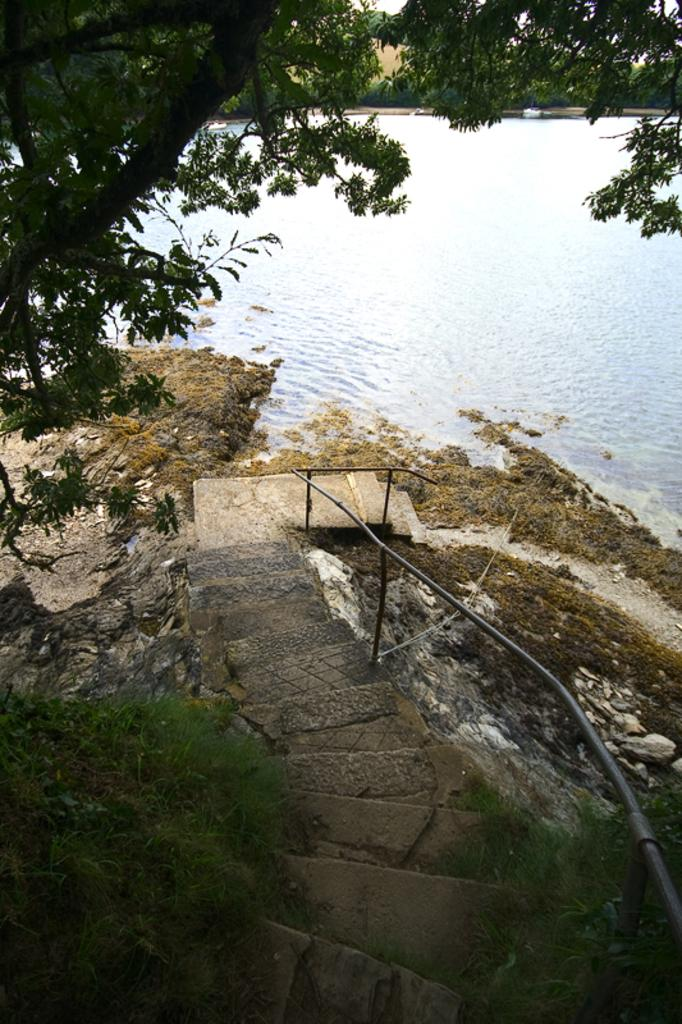What type of vegetation is present in the image? There are trees in the image. What material are the rods made of in the image? The rods in the image are made of metal. What natural element can be seen in the image? Water is visible in the image. What type of sound can be heard coming from the swing in the image? There is no swing present in the image, so no sound can be heard from it. 